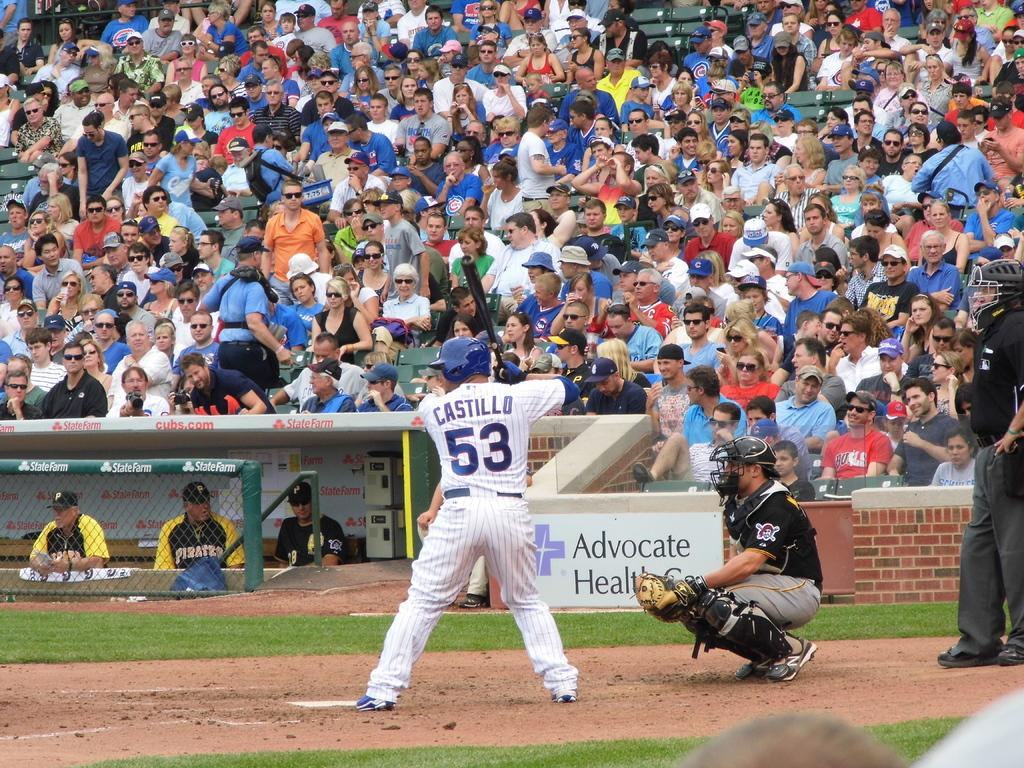Provide a one-sentence caption for the provided image. A baseball number 53 with the last name Castillo attempts to hit a ball in a game of baseball. 